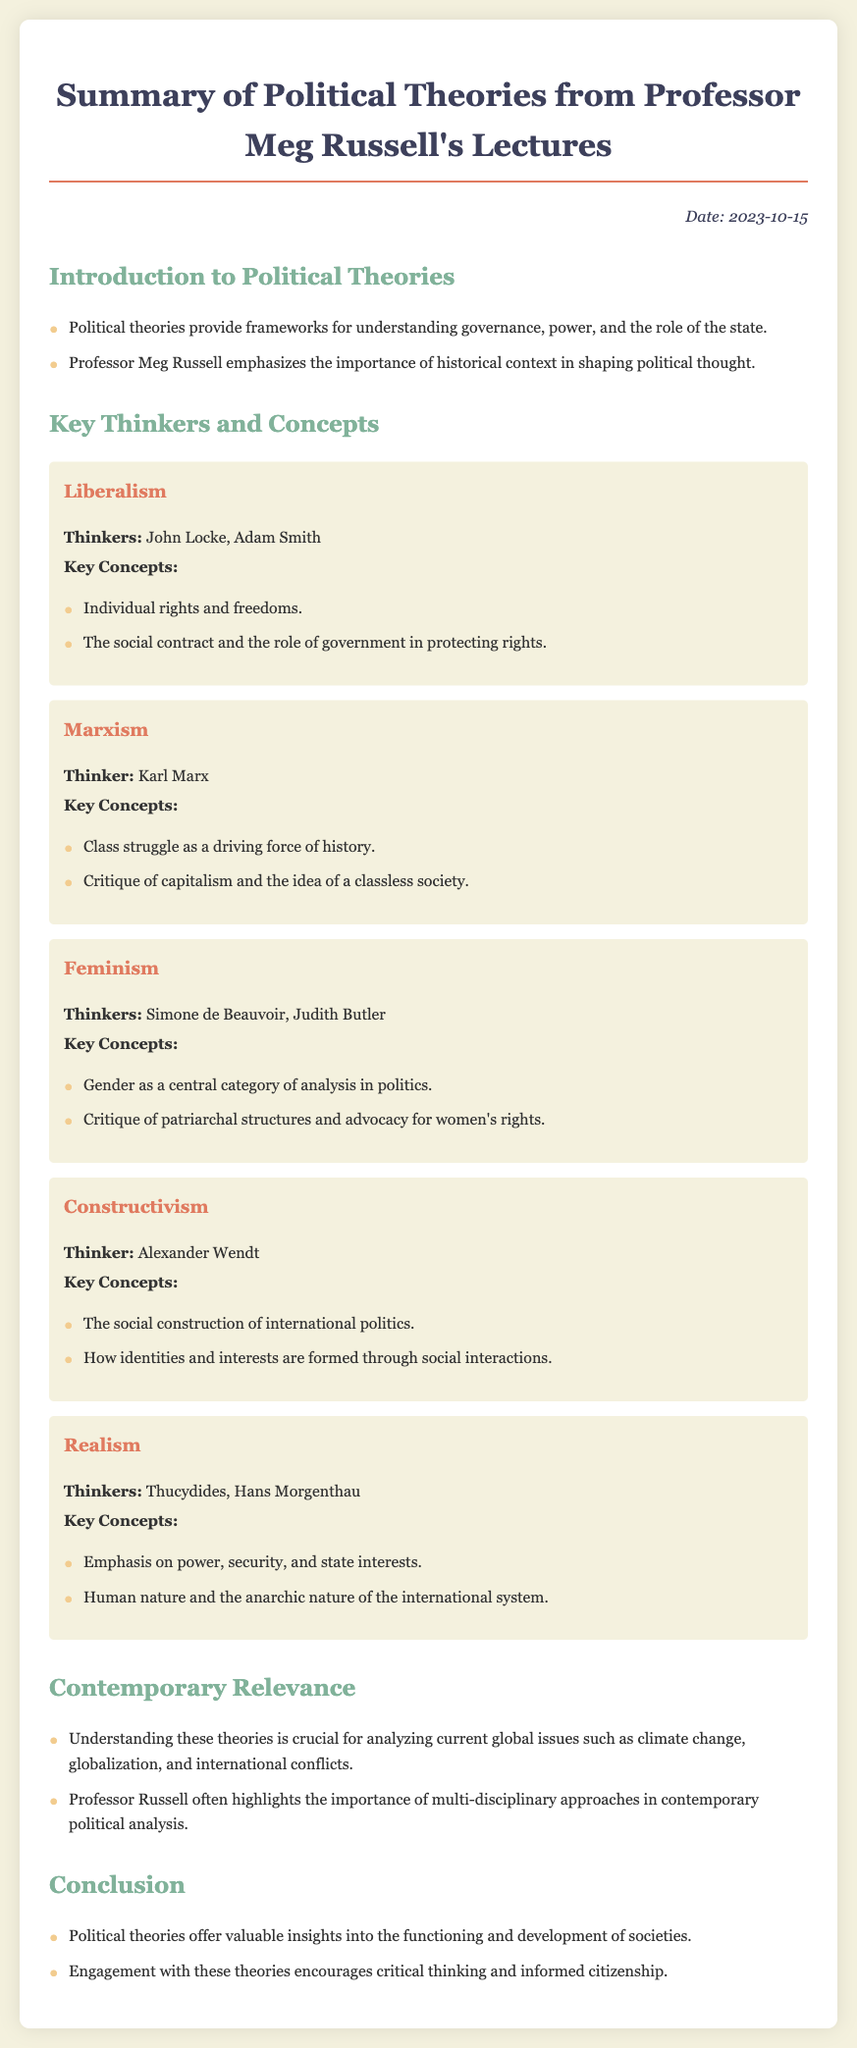What is the date of the lecture summary? The date is specified in the document, which is 2023-10-15.
Answer: 2023-10-15 Who is a key thinker associated with Liberalism? The document lists John Locke and Adam Smith as key thinkers of Liberalism.
Answer: John Locke What is a key concept of Marxism? The document mentions class struggle as a driving force of history as a fundamental concept of Marxism.
Answer: Class struggle Which theory emphasizes gender as a central category of analysis? The document states that Feminism critiques patriarchal structures and focuses on gender in politics.
Answer: Feminism Who emphasized the social construction of international politics? The document attributes this emphasis to Alexander Wendt under the theory of Constructivism.
Answer: Alexander Wendt What is a common critique found in Feminism? The document states that Feminism includes a critique of patriarchal structures.
Answer: Patriarchal structures How many main theories are summarized in the notes? The document provides a summary of five main theories of political thought.
Answer: Five What does Professor Russell highlight about contemporary political analysis? The document notes that Professor Russell emphasizes multi-disciplinary approaches in contemporary political analysis.
Answer: Multi-disciplinary approaches 